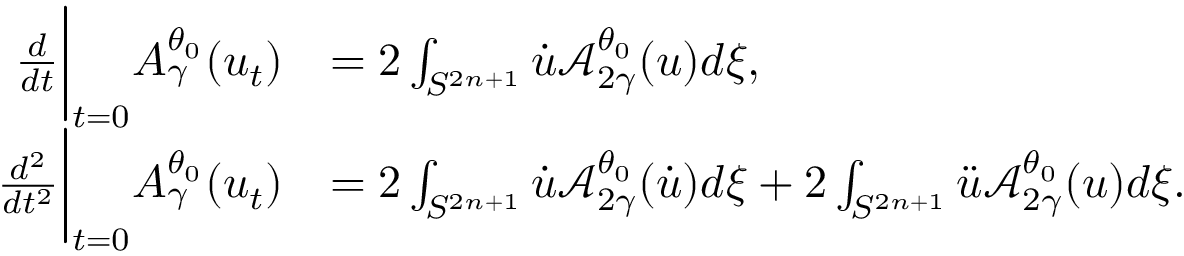Convert formula to latex. <formula><loc_0><loc_0><loc_500><loc_500>\begin{array} { r l } { \frac { d } { d t } \left | _ { t = 0 } A _ { \gamma } ^ { \theta _ { 0 } } ( u _ { t } ) } & { = 2 \int _ { S ^ { 2 n + 1 } } \dot { u } \mathcal { A } _ { 2 \gamma } ^ { \theta _ { 0 } } ( u ) d \xi , } \\ { \frac { d ^ { 2 } } { d t ^ { 2 } } \right | _ { t = 0 } A _ { \gamma } ^ { \theta _ { 0 } } ( u _ { t } ) } & { = 2 \int _ { S ^ { 2 n + 1 } } \dot { u } \mathcal { A } _ { 2 \gamma } ^ { \theta _ { 0 } } ( \dot { u } ) d \xi + 2 \int _ { S ^ { 2 n + 1 } } \ddot { u } \mathcal { A } _ { 2 \gamma } ^ { \theta _ { 0 } } ( u ) d \xi . } \end{array}</formula> 